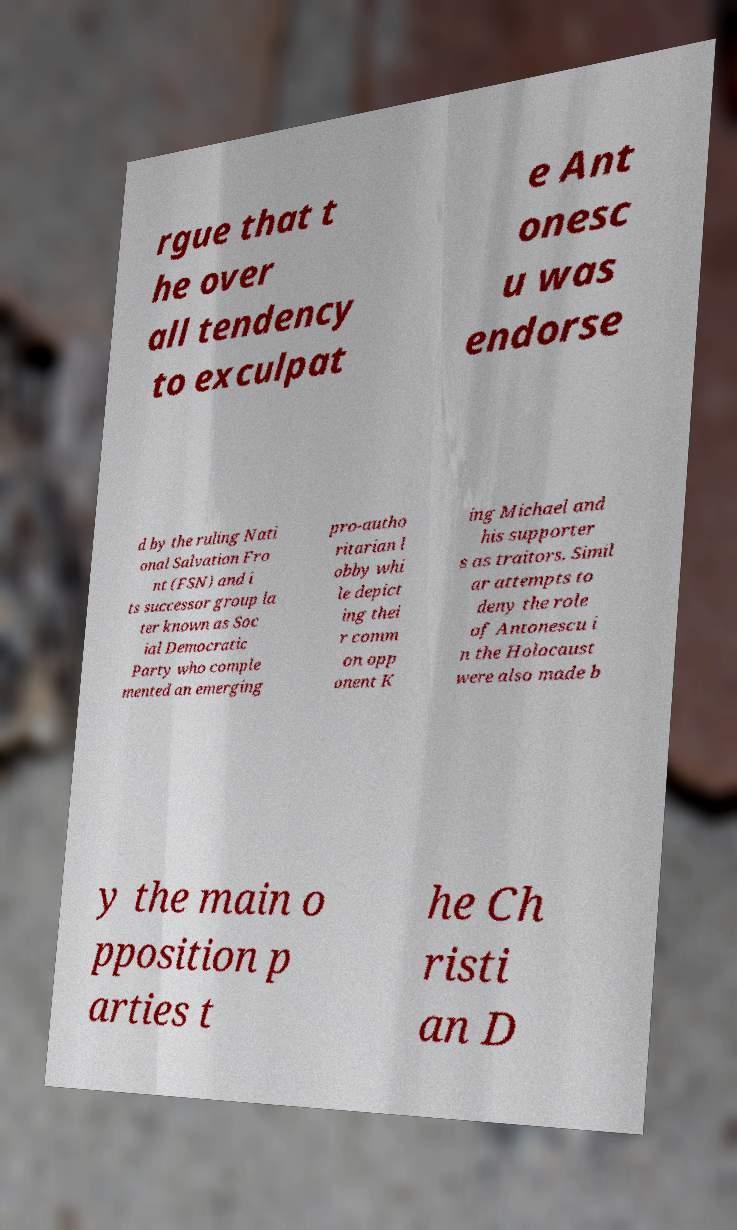Could you extract and type out the text from this image? rgue that t he over all tendency to exculpat e Ant onesc u was endorse d by the ruling Nati onal Salvation Fro nt (FSN) and i ts successor group la ter known as Soc ial Democratic Party who comple mented an emerging pro-autho ritarian l obby whi le depict ing thei r comm on opp onent K ing Michael and his supporter s as traitors. Simil ar attempts to deny the role of Antonescu i n the Holocaust were also made b y the main o pposition p arties t he Ch risti an D 